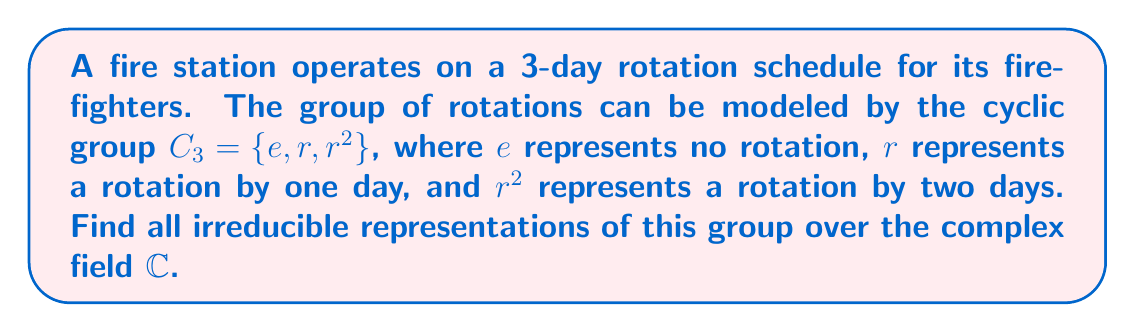Could you help me with this problem? To find the irreducible representations of the cyclic group $C_3$, we'll follow these steps:

1) First, recall that for a finite abelian group, the number of irreducible representations is equal to the order of the group. $C_3$ has order 3, so we expect 3 irreducible representations.

2) For cyclic groups, all irreducible representations are one-dimensional over $\mathbb{C}$. This means each representation will map group elements to complex numbers.

3) Let $\rho$ be an irreducible representation of $C_3$. We need to find $\rho(e)$, $\rho(r)$, and $\rho(r^2)$.

4) For any representation, $\rho(e) = 1$ (the identity element always maps to 1).

5) Let $\omega = \rho(r)$. Since $r^3 = e$, we must have $\omega^3 = 1$.

6) The solutions to $\omega^3 = 1$ are the complex cube roots of unity:
   $\omega_0 = 1$, $\omega_1 = e^{2\pi i/3} = -\frac{1}{2} + i\frac{\sqrt{3}}{2}$, $\omega_2 = e^{4\pi i/3} = -\frac{1}{2} - i\frac{\sqrt{3}}{2}$

7) These give us our three irreducible representations:
   $\rho_0: e \mapsto 1, r \mapsto 1, r^2 \mapsto 1$
   $\rho_1: e \mapsto 1, r \mapsto \omega_1, r^2 \mapsto \omega_1^2 = \omega_2$
   $\rho_2: e \mapsto 1, r \mapsto \omega_2, r^2 \mapsto \omega_2^2 = \omega_1$

These three representations are distinct and irreducible, and they exhaust all possibilities for irreducible representations of $C_3$ over $\mathbb{C}$.
Answer: $\rho_0(r) = 1$, $\rho_1(r) = e^{2\pi i/3}$, $\rho_2(r) = e^{4\pi i/3}$ 